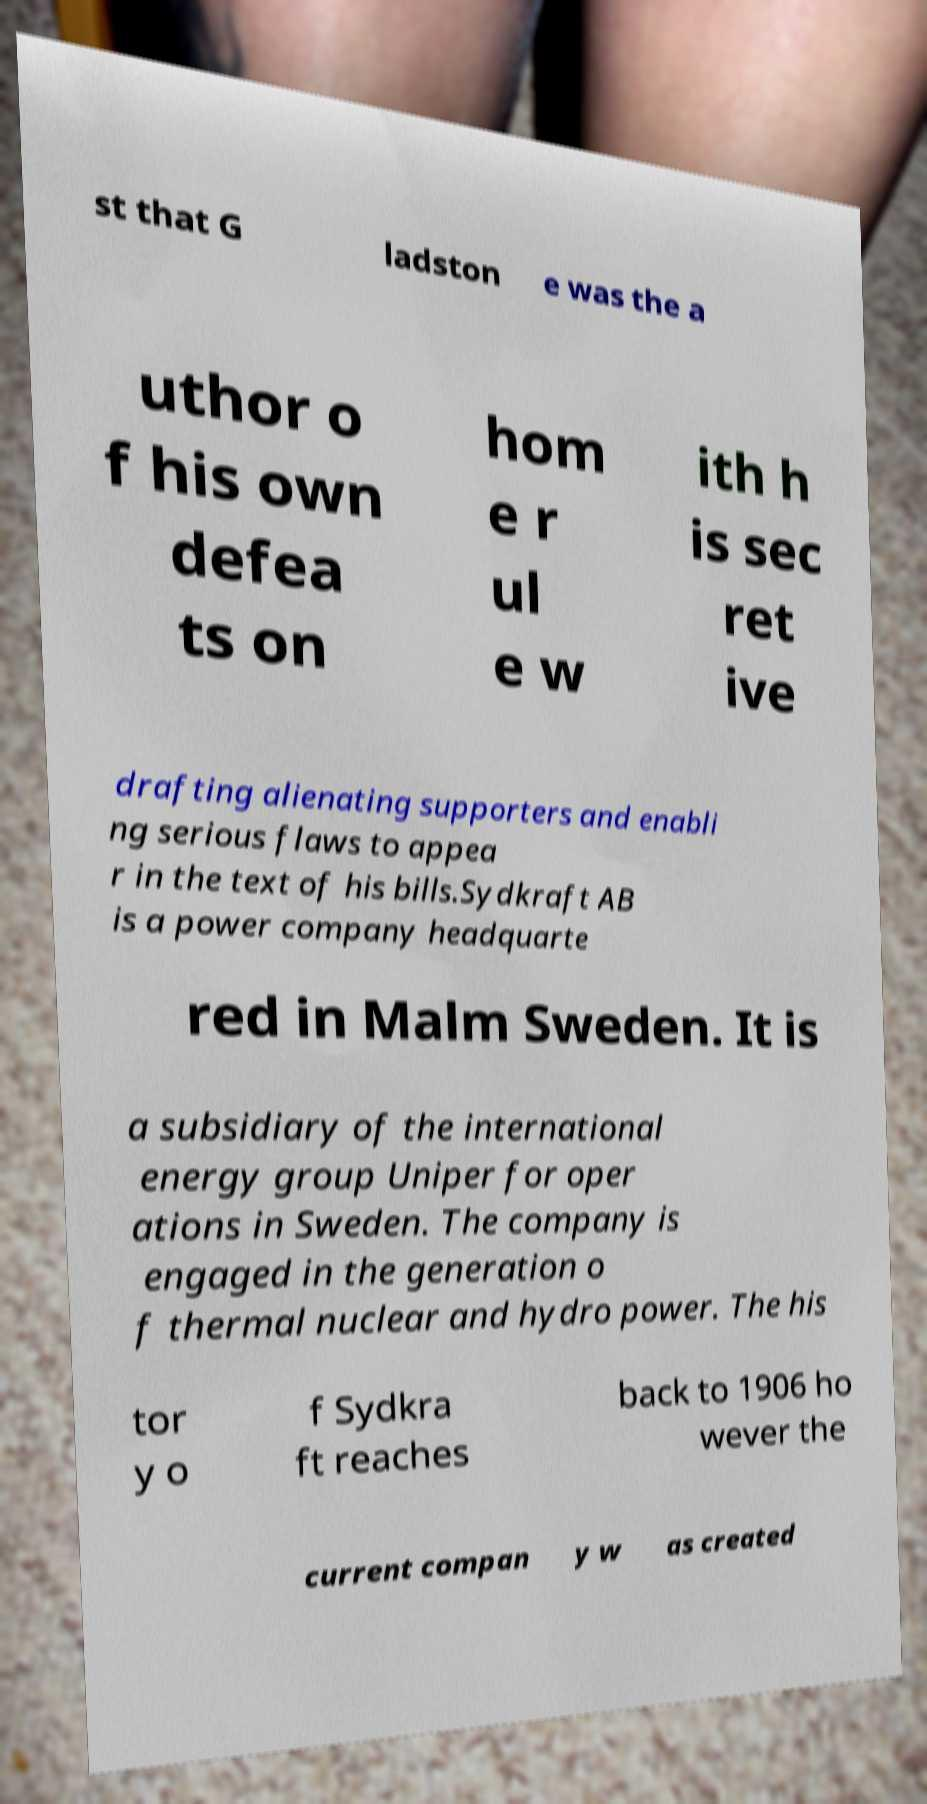Could you assist in decoding the text presented in this image and type it out clearly? st that G ladston e was the a uthor o f his own defea ts on hom e r ul e w ith h is sec ret ive drafting alienating supporters and enabli ng serious flaws to appea r in the text of his bills.Sydkraft AB is a power company headquarte red in Malm Sweden. It is a subsidiary of the international energy group Uniper for oper ations in Sweden. The company is engaged in the generation o f thermal nuclear and hydro power. The his tor y o f Sydkra ft reaches back to 1906 ho wever the current compan y w as created 